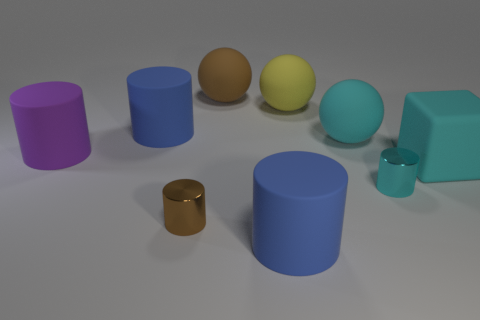The object that is both behind the cyan sphere and left of the brown metal cylinder has what shape?
Provide a short and direct response. Cylinder. Is there a cyan cylinder of the same size as the yellow ball?
Your answer should be very brief. No. There is a large blue matte object that is behind the cyan rubber ball; is it the same shape as the large purple object?
Provide a succinct answer. Yes. Do the brown shiny thing and the purple thing have the same shape?
Give a very brief answer. Yes. Is there a blue rubber object that has the same shape as the tiny cyan metallic object?
Ensure brevity in your answer.  Yes. What shape is the big cyan object on the right side of the cylinder that is to the right of the yellow ball?
Ensure brevity in your answer.  Cube. There is a large cylinder in front of the large purple rubber thing; what color is it?
Make the answer very short. Blue. There is a brown object that is made of the same material as the small cyan cylinder; what is its size?
Provide a short and direct response. Small. The brown metallic thing that is the same shape as the small cyan thing is what size?
Offer a very short reply. Small. Are there any yellow objects?
Your answer should be compact. Yes. 